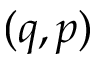Convert formula to latex. <formula><loc_0><loc_0><loc_500><loc_500>( q , p )</formula> 